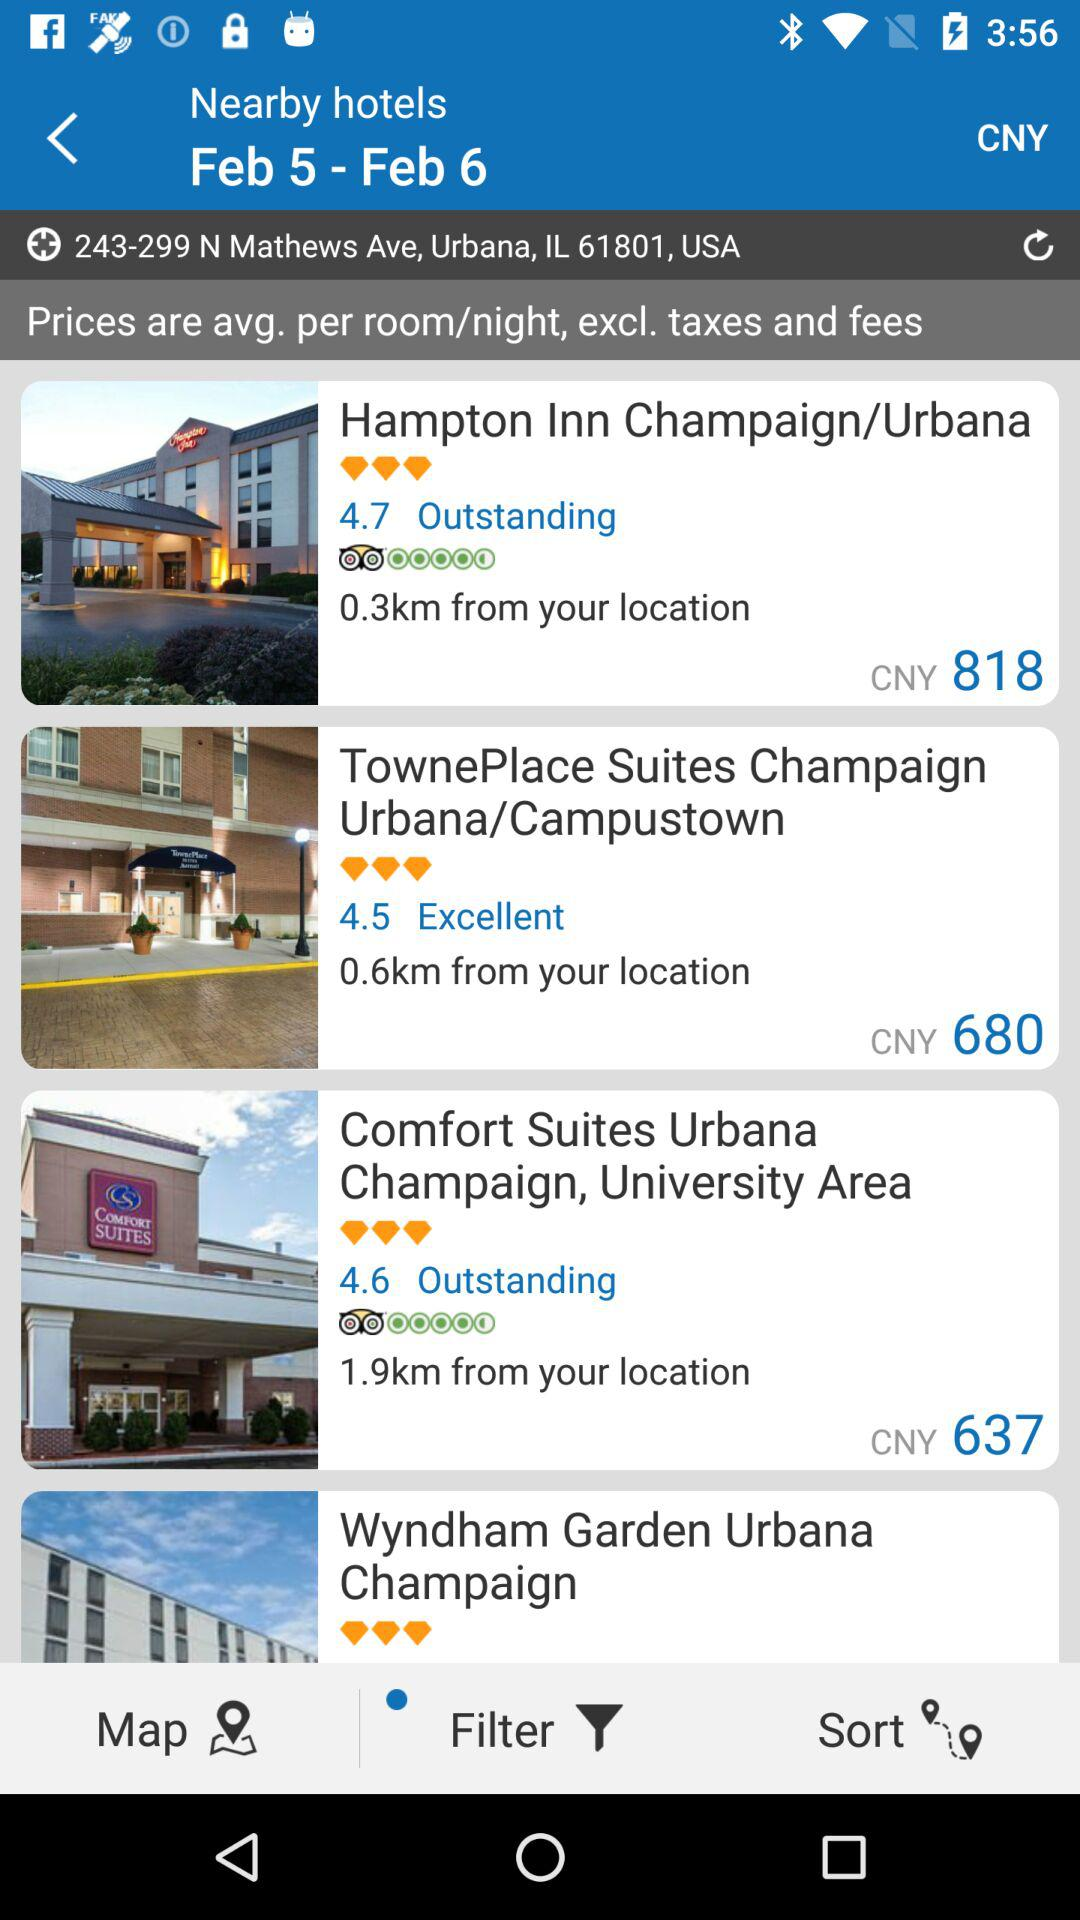What is the selected date range? The selected date range is from February 5 to February 6. 